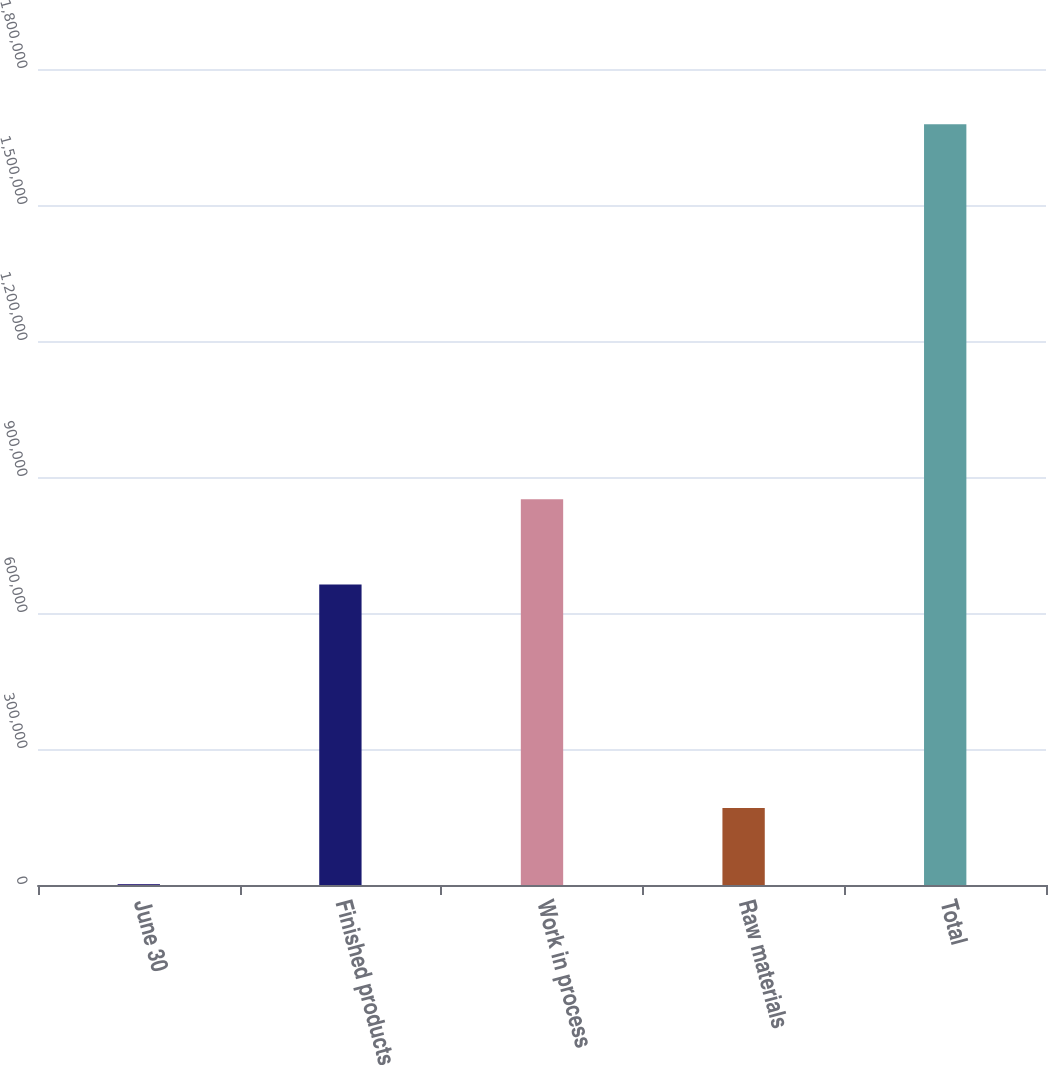<chart> <loc_0><loc_0><loc_500><loc_500><bar_chart><fcel>June 30<fcel>Finished products<fcel>Work in process<fcel>Raw materials<fcel>Total<nl><fcel>2019<fcel>663068<fcel>850778<fcel>169630<fcel>1.67813e+06<nl></chart> 